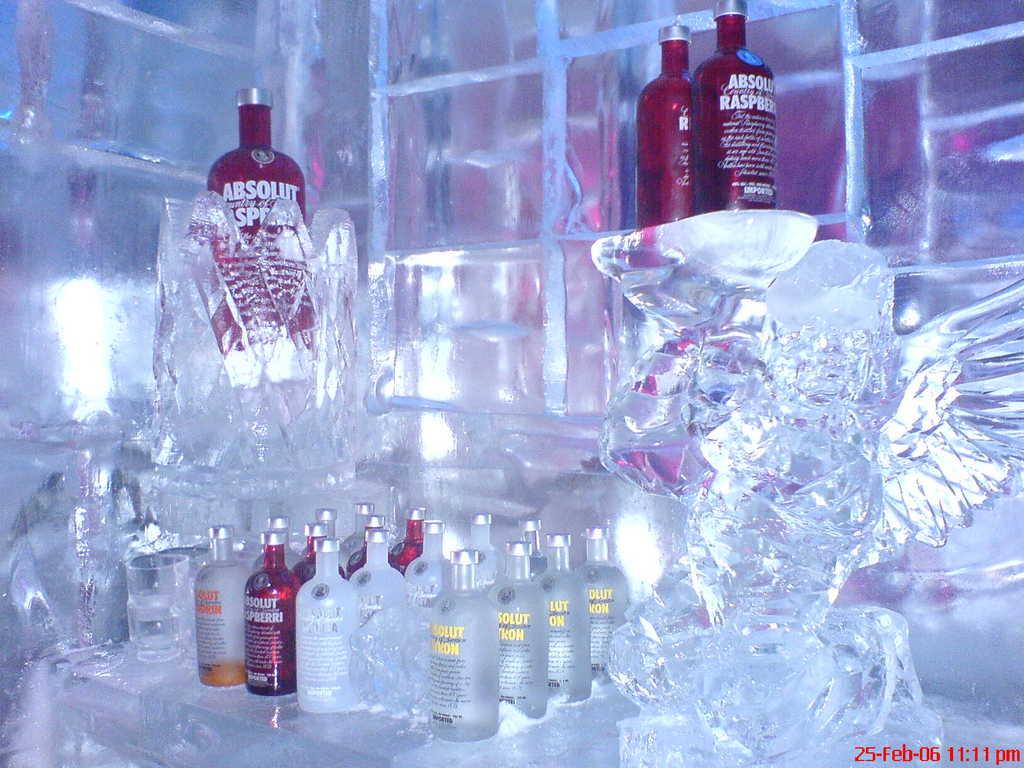What brand is this vodka?
Offer a very short reply. Absolut. What fruit is mentioned on the large bottles up above?
Provide a succinct answer. Raspberry. 